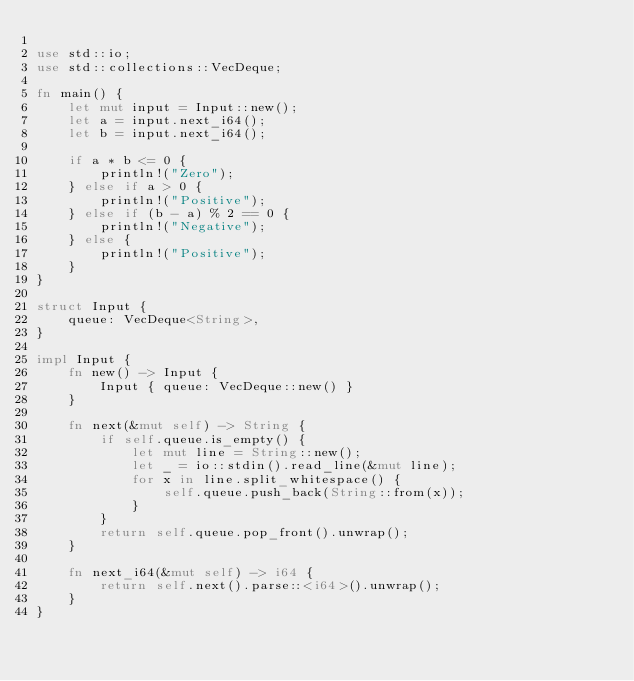<code> <loc_0><loc_0><loc_500><loc_500><_Rust_>
use std::io;
use std::collections::VecDeque;

fn main() {
    let mut input = Input::new();
    let a = input.next_i64();
    let b = input.next_i64();

    if a * b <= 0 {
        println!("Zero");
    } else if a > 0 {
        println!("Positive");
    } else if (b - a) % 2 == 0 {
        println!("Negative");
    } else {
        println!("Positive");
    }
}

struct Input {
    queue: VecDeque<String>,
}

impl Input {
    fn new() -> Input {
        Input { queue: VecDeque::new() }
    }

    fn next(&mut self) -> String {
        if self.queue.is_empty() {
            let mut line = String::new();
            let _ = io::stdin().read_line(&mut line);
            for x in line.split_whitespace() {
                self.queue.push_back(String::from(x));
            }
        }
        return self.queue.pop_front().unwrap();
    }

    fn next_i64(&mut self) -> i64 {
        return self.next().parse::<i64>().unwrap();
    }
}
</code> 